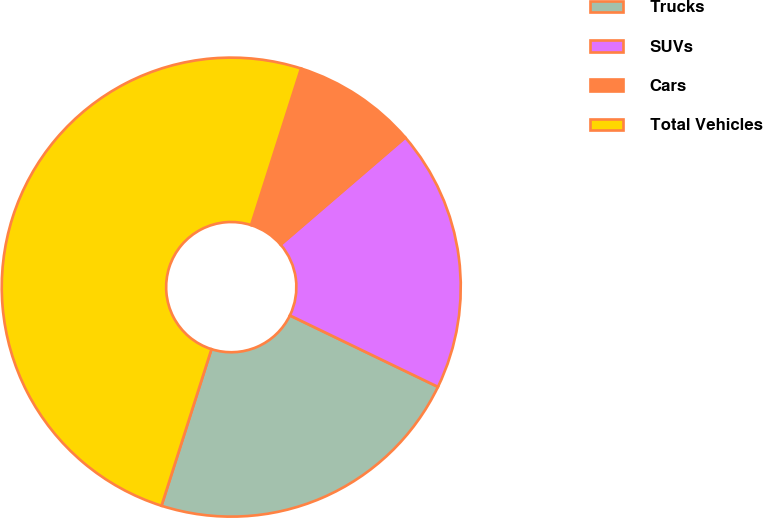<chart> <loc_0><loc_0><loc_500><loc_500><pie_chart><fcel>Trucks<fcel>SUVs<fcel>Cars<fcel>Total Vehicles<nl><fcel>22.76%<fcel>18.46%<fcel>8.78%<fcel>50.0%<nl></chart> 